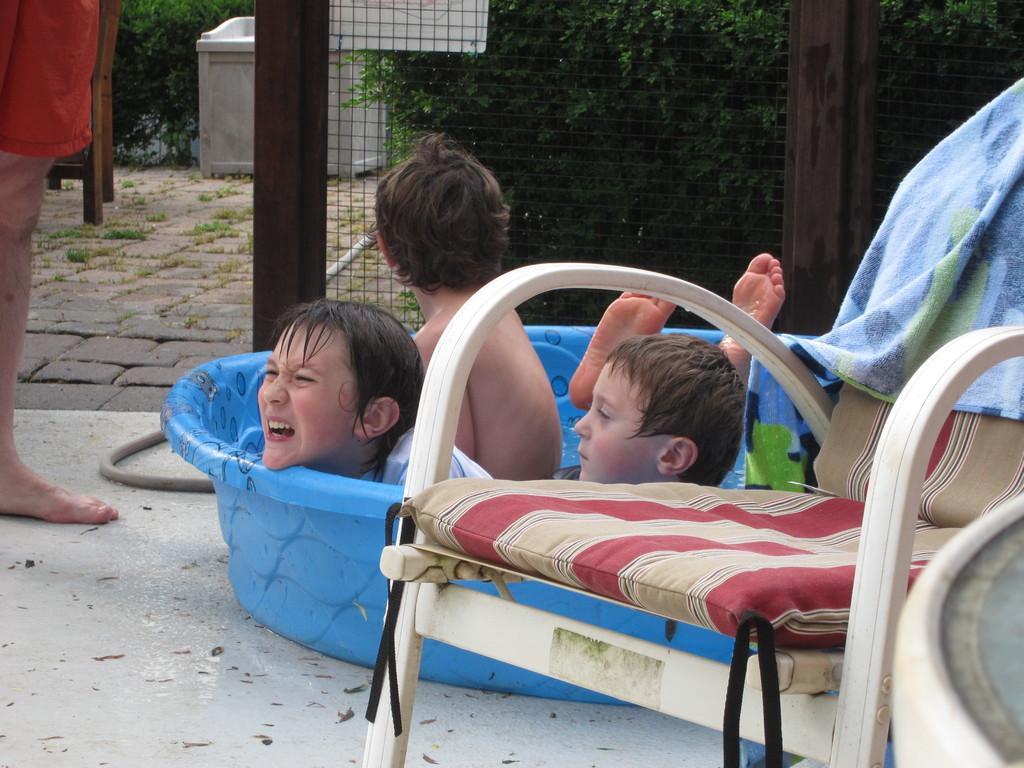In one or two sentences, can you explain what this image depicts? In this picture we can see three boys are in a tub and aside to this we have a chair with towel on it and in the background we can see tree, fence, chair, some person standing, pipe. 